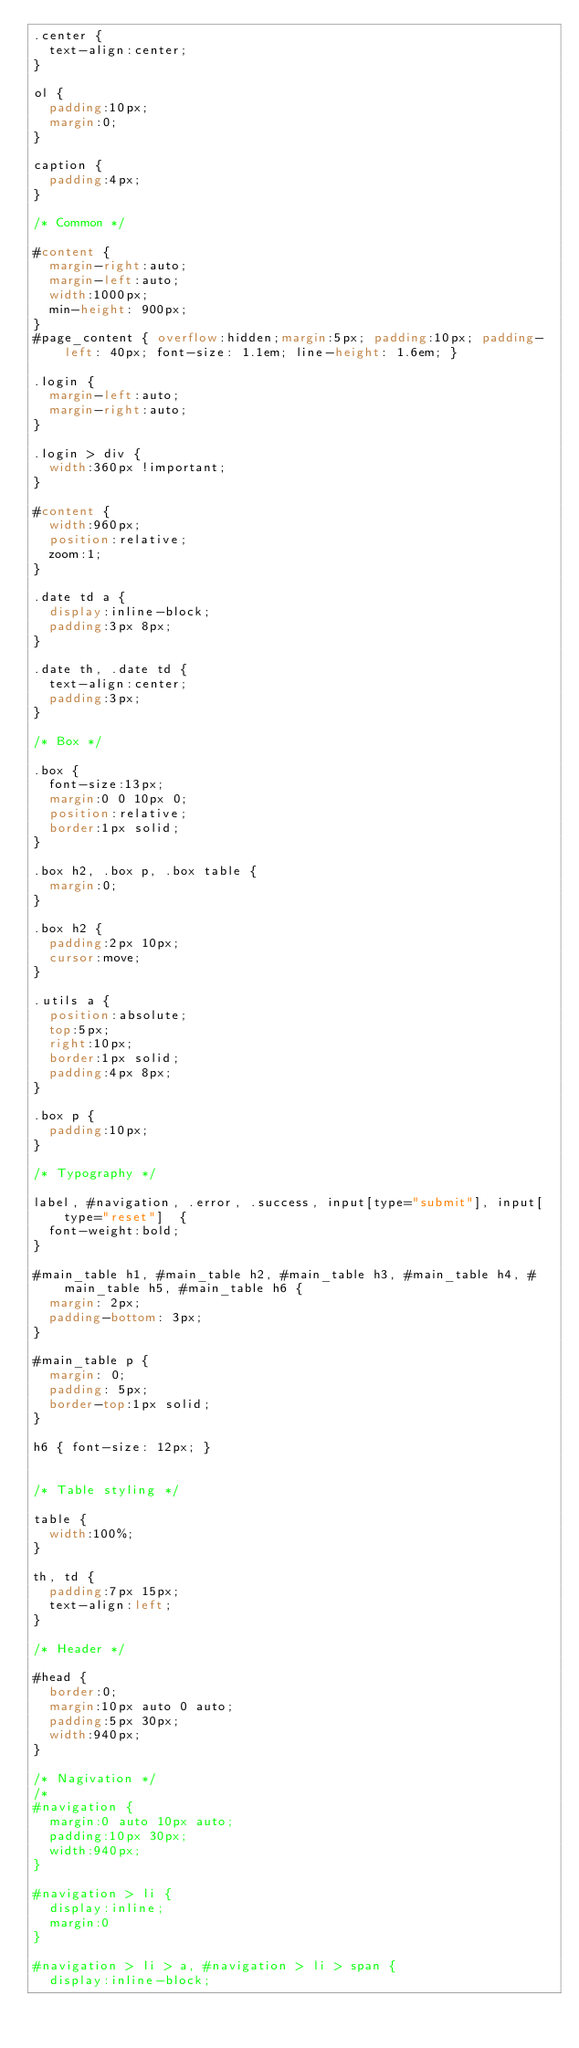Convert code to text. <code><loc_0><loc_0><loc_500><loc_500><_CSS_>.center {
	text-align:center;
}

ol {
	padding:10px;
	margin:0;
}

caption {
	padding:4px;
}

/* Common */

#content {
	margin-right:auto;
	margin-left:auto;
	width:1000px;
	min-height: 900px;
}
#page_content { overflow:hidden;margin:5px; padding:10px; padding-left: 40px; font-size: 1.1em; line-height: 1.6em; }

.login {
	margin-left:auto;
	margin-right:auto;
}

.login > div {
	width:360px !important;
}

#content {
	width:960px;
	position:relative;
	zoom:1;
}

.date td a {
	display:inline-block;
	padding:3px 8px;
}

.date th, .date td {
	text-align:center;
	padding:3px;
}

/* Box */

.box {
	font-size:13px;
	margin:0 0 10px 0;
	position:relative;
	border:1px solid;
}

.box h2, .box p, .box table {
	margin:0;
}

.box h2 {
	padding:2px 10px;
	cursor:move;
}

.utils a {
	position:absolute;
	top:5px;
	right:10px;
	border:1px solid;
	padding:4px 8px;
}

.box p {
	padding:10px;
}

/* Typography */

label, #navigation, .error, .success, input[type="submit"], input[type="reset"]  {
	font-weight:bold;
}

#main_table h1, #main_table h2, #main_table h3, #main_table h4, #main_table h5, #main_table h6 {
	margin: 2px;
	padding-bottom: 3px;
}

#main_table p {
	margin: 0;
	padding: 5px;
	border-top:1px solid;
}

h6 { font-size: 12px; }


/* Table styling */

table {
	width:100%;
}

th, td {
	padding:7px 15px;
	text-align:left;
}

/* Header */

#head {
	border:0;
	margin:10px auto 0 auto;
	padding:5px 30px;
	width:940px;
}

/* Nagivation */
/*
#navigation {
	margin:0 auto 10px auto;
	padding:10px 30px;
	width:940px;
}

#navigation > li {
	display:inline;
	margin:0
}

#navigation > li > a, #navigation > li > span {
	display:inline-block;</code> 